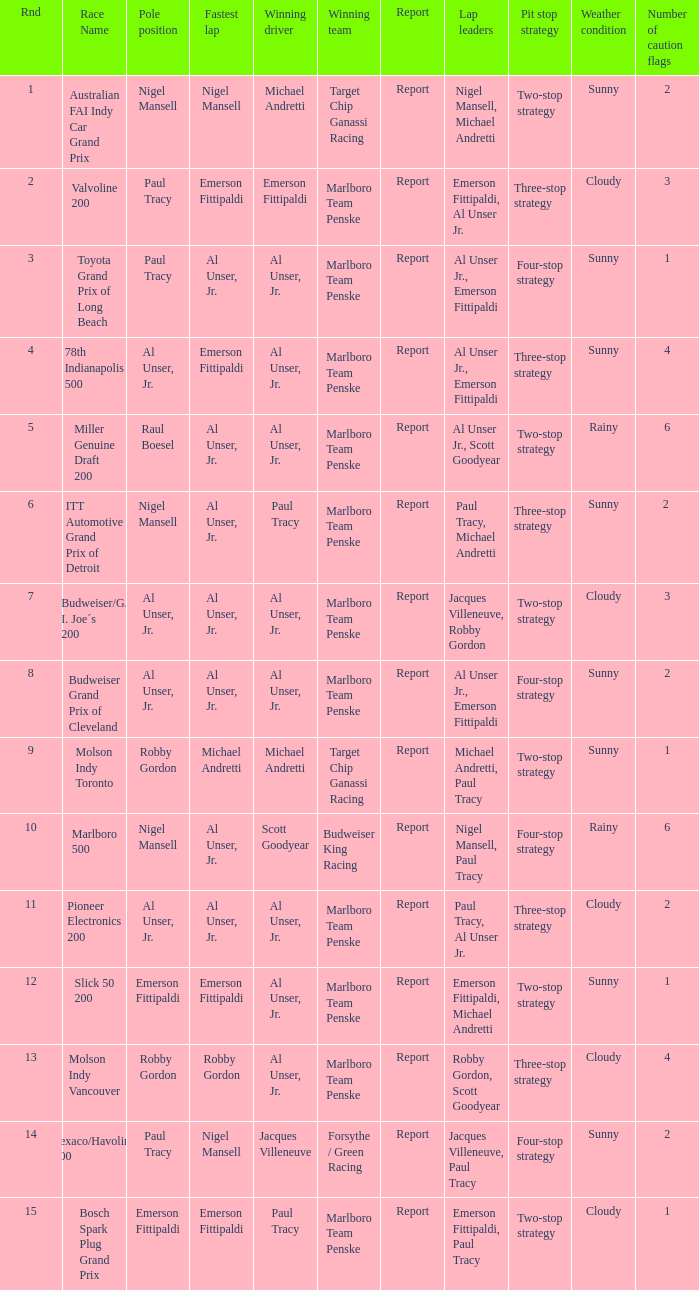What's the report of the race won by Michael Andretti, with Nigel Mansell driving the fastest lap? Report. 